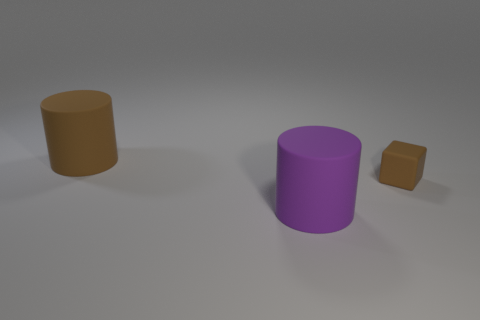Can you guess the software that might have been used to create this 3D render? Without specific indicators, it's challenging to determine the exact software used; however, this 3D scene could have been created with widely used programs like Blender, Autodesk Maya, or 3ds Max. These tools are capable of producing such simple 3D models and rendering them with basic materials and lighting. 